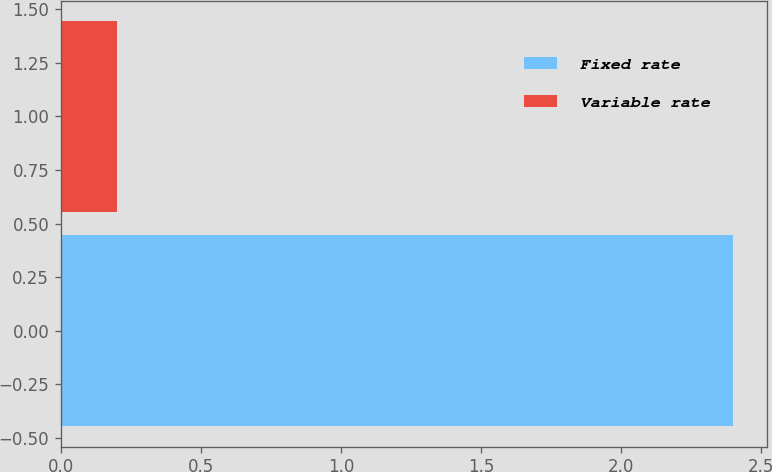Convert chart to OTSL. <chart><loc_0><loc_0><loc_500><loc_500><bar_chart><fcel>Fixed rate<fcel>Variable rate<nl><fcel>2.4<fcel>0.2<nl></chart> 